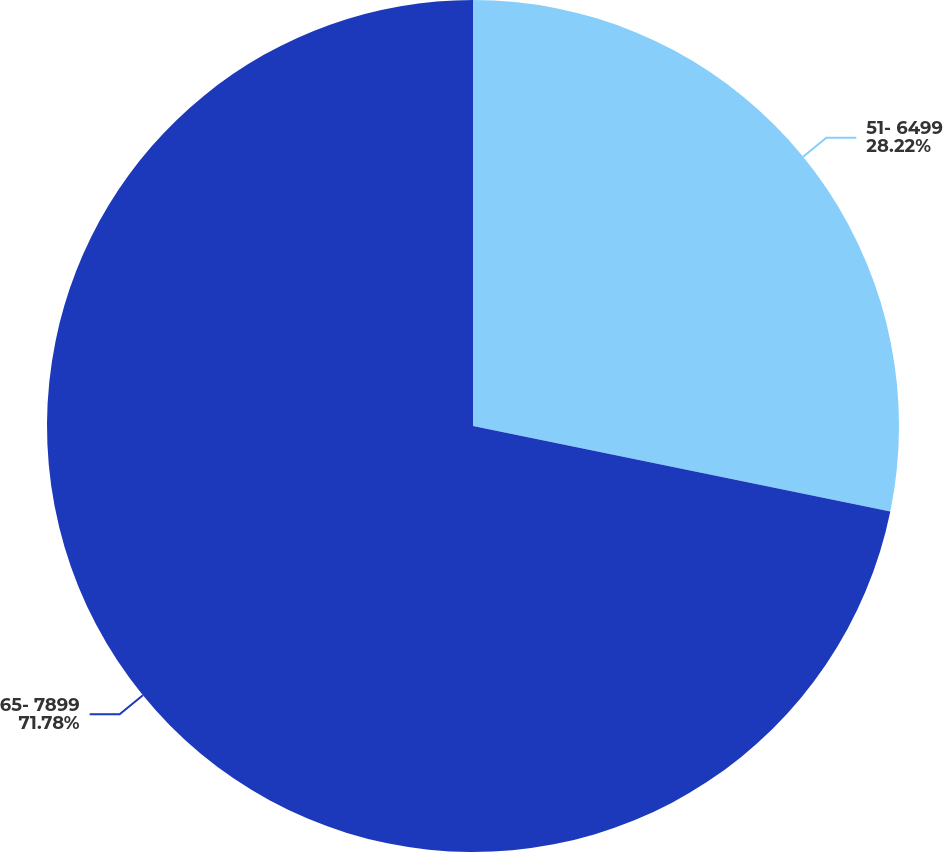<chart> <loc_0><loc_0><loc_500><loc_500><pie_chart><fcel>51- 6499<fcel>65- 7899<nl><fcel>28.22%<fcel>71.78%<nl></chart> 